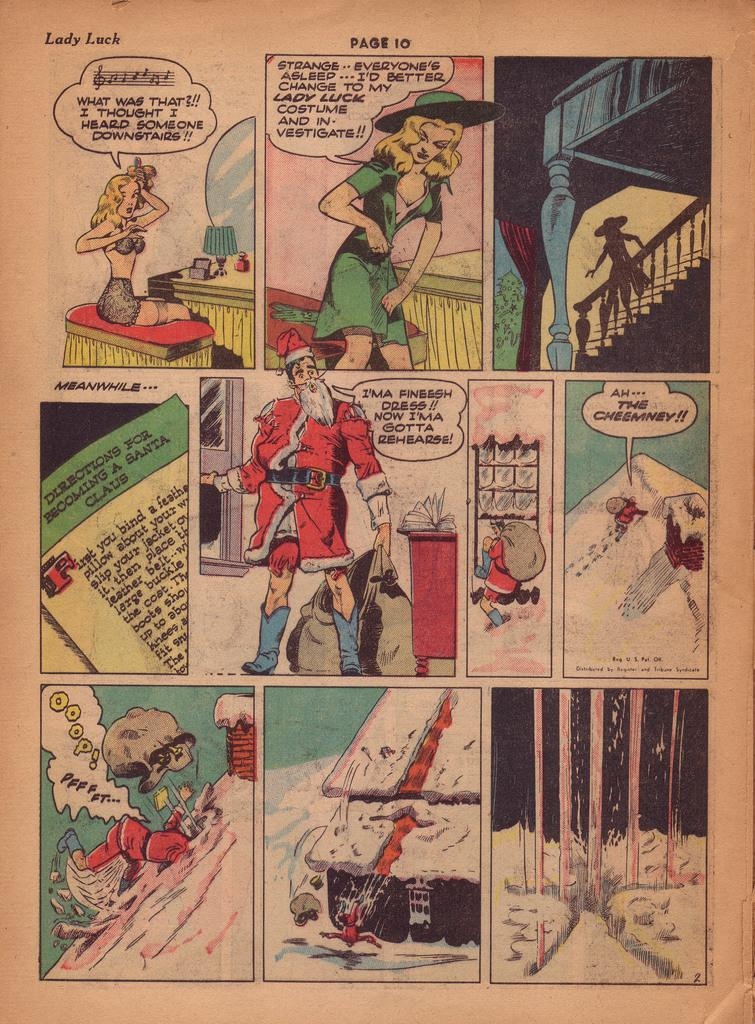<image>
Provide a brief description of the given image. A Christmas themed comic book goes by the title Lady Luck. 